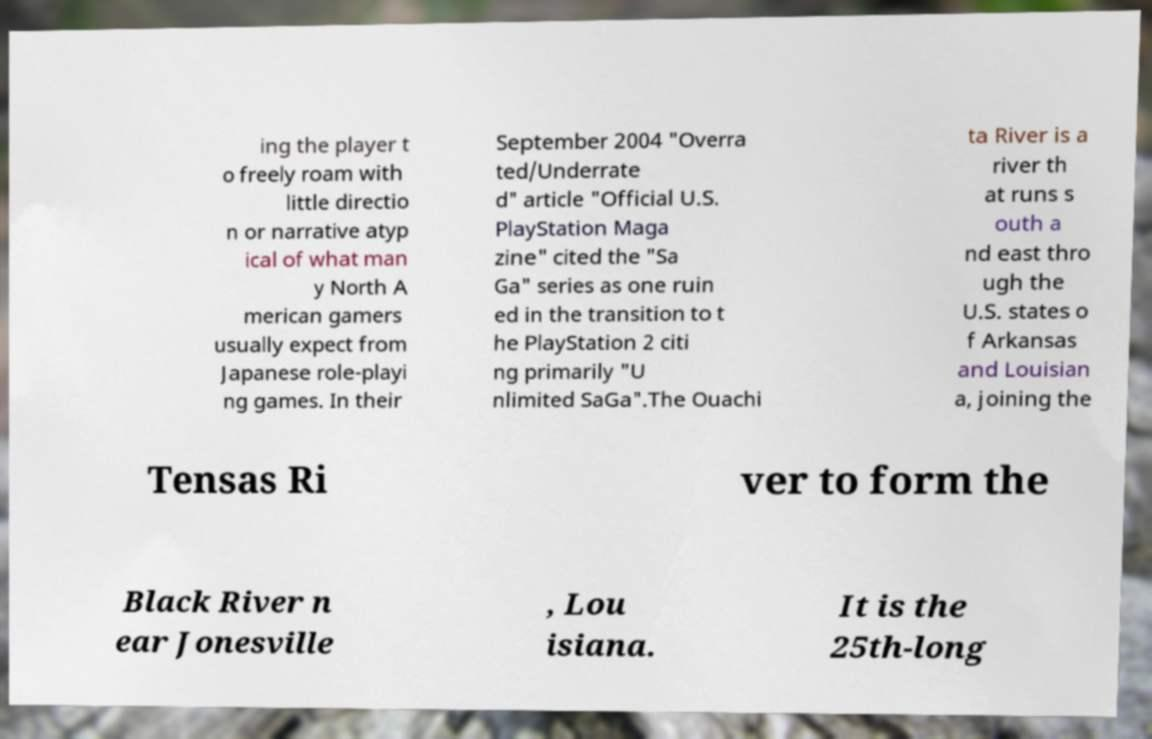Can you read and provide the text displayed in the image?This photo seems to have some interesting text. Can you extract and type it out for me? ing the player t o freely roam with little directio n or narrative atyp ical of what man y North A merican gamers usually expect from Japanese role-playi ng games. In their September 2004 "Overra ted/Underrate d" article "Official U.S. PlayStation Maga zine" cited the "Sa Ga" series as one ruin ed in the transition to t he PlayStation 2 citi ng primarily "U nlimited SaGa".The Ouachi ta River is a river th at runs s outh a nd east thro ugh the U.S. states o f Arkansas and Louisian a, joining the Tensas Ri ver to form the Black River n ear Jonesville , Lou isiana. It is the 25th-long 